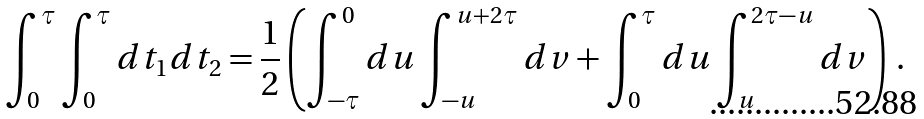<formula> <loc_0><loc_0><loc_500><loc_500>\int _ { 0 } ^ { \tau } \int _ { 0 } ^ { \tau } d t _ { 1 } d t _ { 2 } = \frac { 1 } { 2 } \left ( \int _ { - \tau } ^ { 0 } d u \int _ { - u } ^ { u + 2 \tau } d v + \int _ { 0 } ^ { \tau } d u \int _ { u } ^ { 2 \tau - u } d v \right ) \, .</formula> 